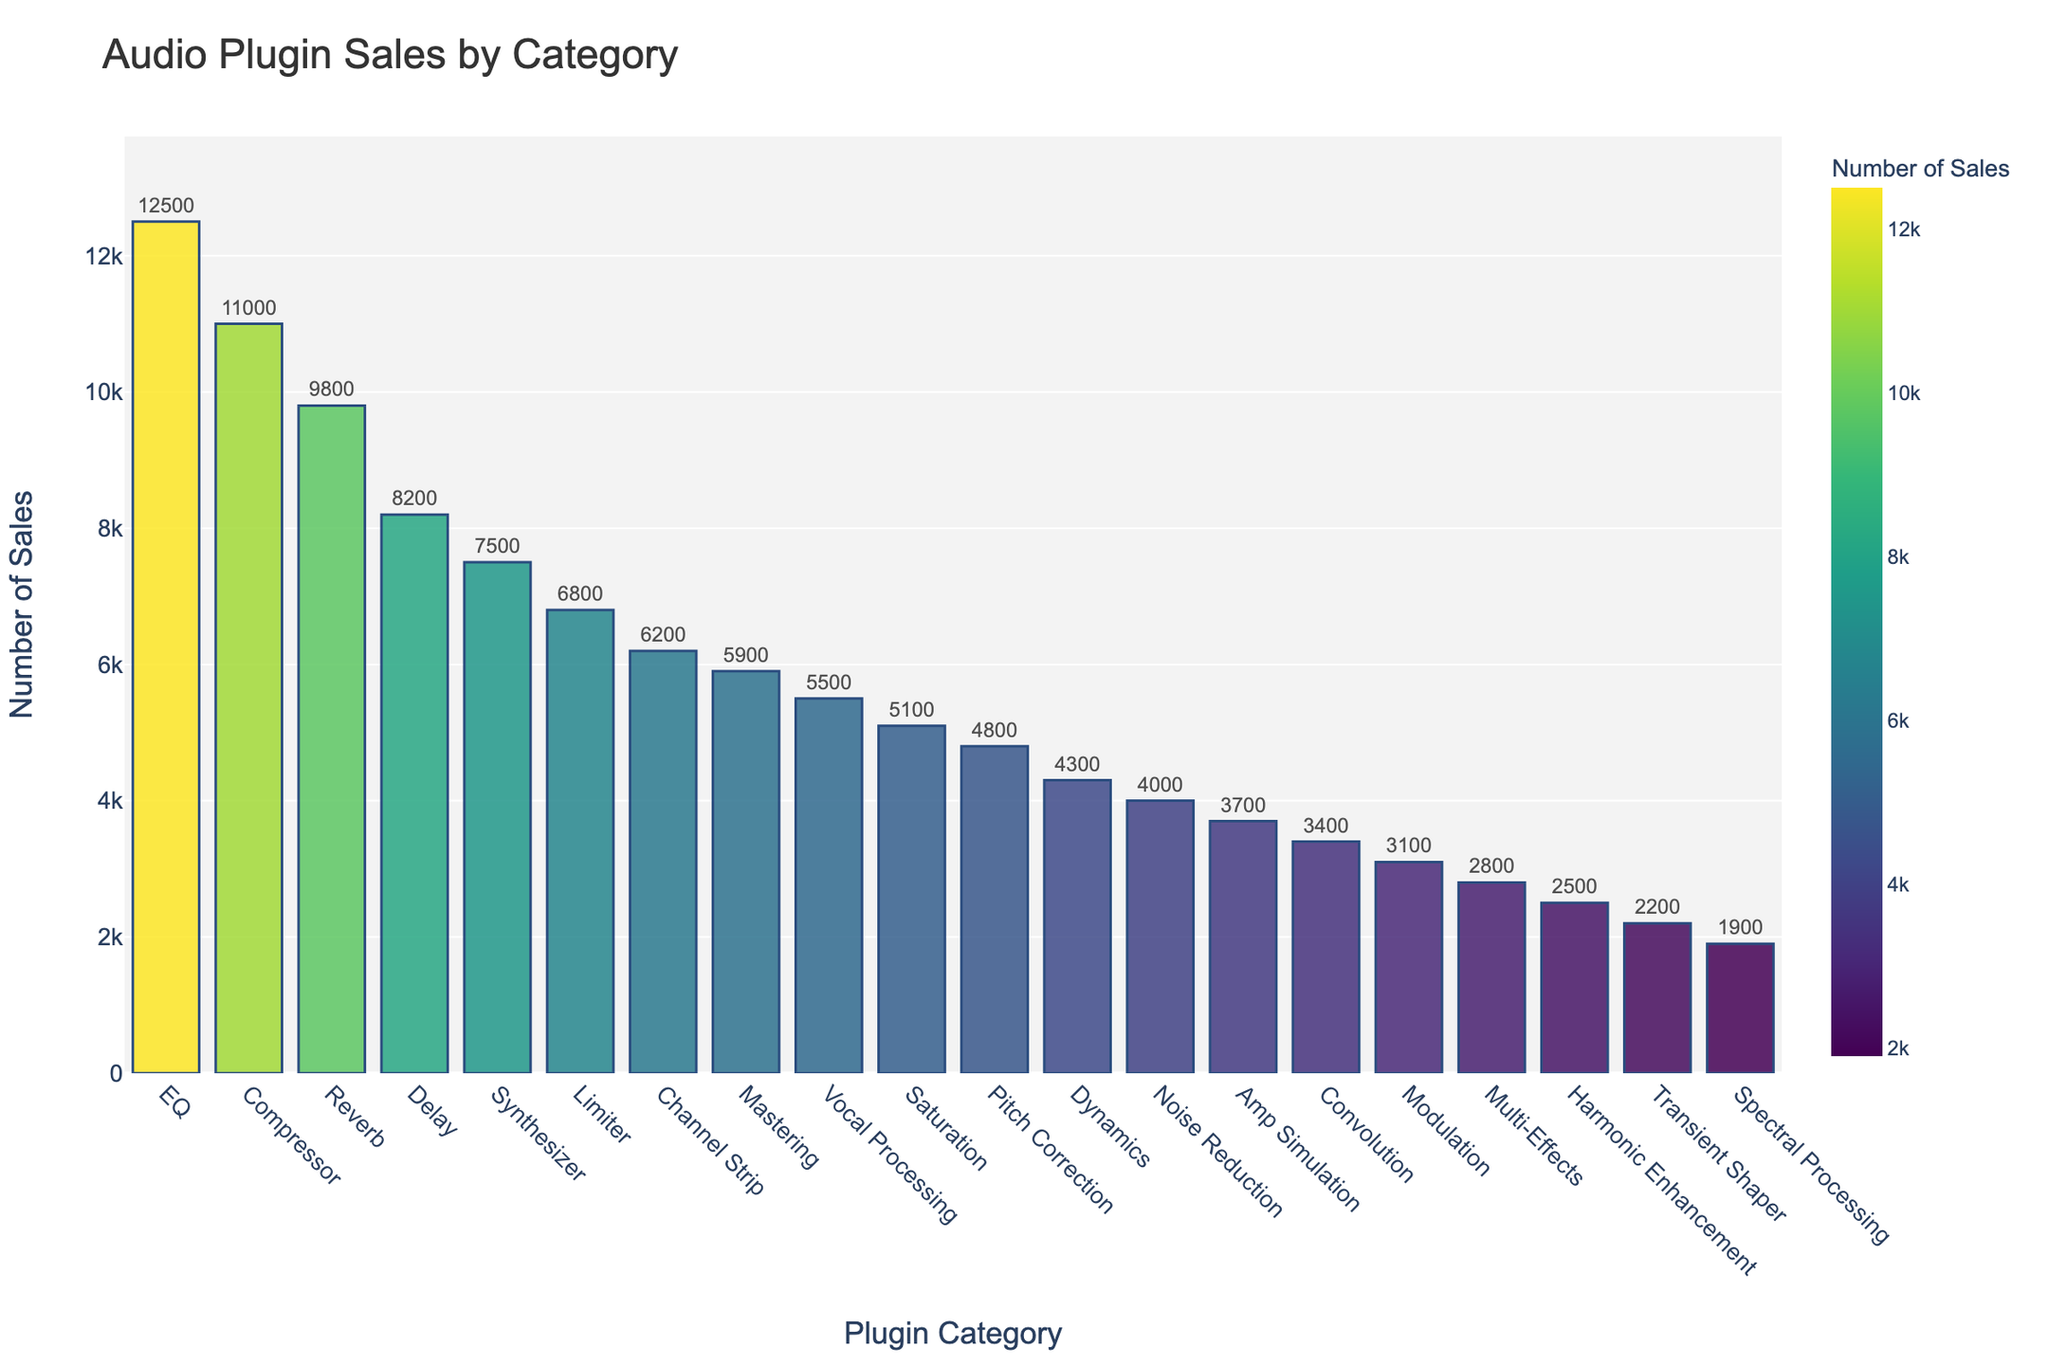Which plugin category has the highest sales? The plugin category with the highest sales is identified by looking for the tallest bar in the bar chart. The tallest bar corresponds to EQ, with sales of 12,500.
Answer: EQ What is the total sales for the Compressor and Reverb categories combined? Add the sales for the Compressor and Reverb categories: 11,000 (Compressor) + 9,800 (Reverb) = 20,800.
Answer: 20,800 Which plugin category has the lowest sales? The category with the lowest sales is identified by finding the shortest bar in the bar chart. The shortest bar corresponds to Spectral Processing, with sales of 1,900.
Answer: Spectral Processing How do the sales of the Delay category compare to the sales of the Synthesizer category? Compare the heights of the bars for the Delay and Synthesizer categories. The Delay category has sales of 8,200, while the Synthesizer category has sales of 7,500. Delay has higher sales than Synthesizer.
Answer: Delay has higher sales What is the difference in sales between the Limiter and Vocal Processing categories? Subtract the sales of Vocal Processing from the sales of Limiter: 6,800 (Limiter) - 5,500 (Vocal Processing) = 1,300.
Answer: 1,300 What is the average sales value of the top five selling plugin categories? Calculate the sum of the sales for the top five categories and divide by five: (12,500 + 11,000 + 9,800 + 8,200 + 7,500) / 5 = 49,000 / 5 = 9,800.
Answer: 9,800 How many plugin categories have sales greater than 5,000? Count the number of bars that extend above the 5,000 mark. There are 8 plugin categories with sales exceeding 5,000: EQ, Compressor, Reverb, Delay, Synthesizer, Limiter, Channel Strip, and Mastering.
Answer: 8 Which plugin category is directly in the middle in terms of sales? Arrange the categories in descending order of sales and find the median category. With 20 total categories, the median position is the 10th in the sorted list. The 10th category in descending order is Saturation.
Answer: Saturation What is the combined sales of the three least selling plugin categories? Add the sales of the three lowest categories: Spectral Processing (1,900), Transient Shaper (2,200), and Harmonic Enhancement (2,500): 1,900 + 2,200 + 2,500 = 6,600.
Answer: 6,600 